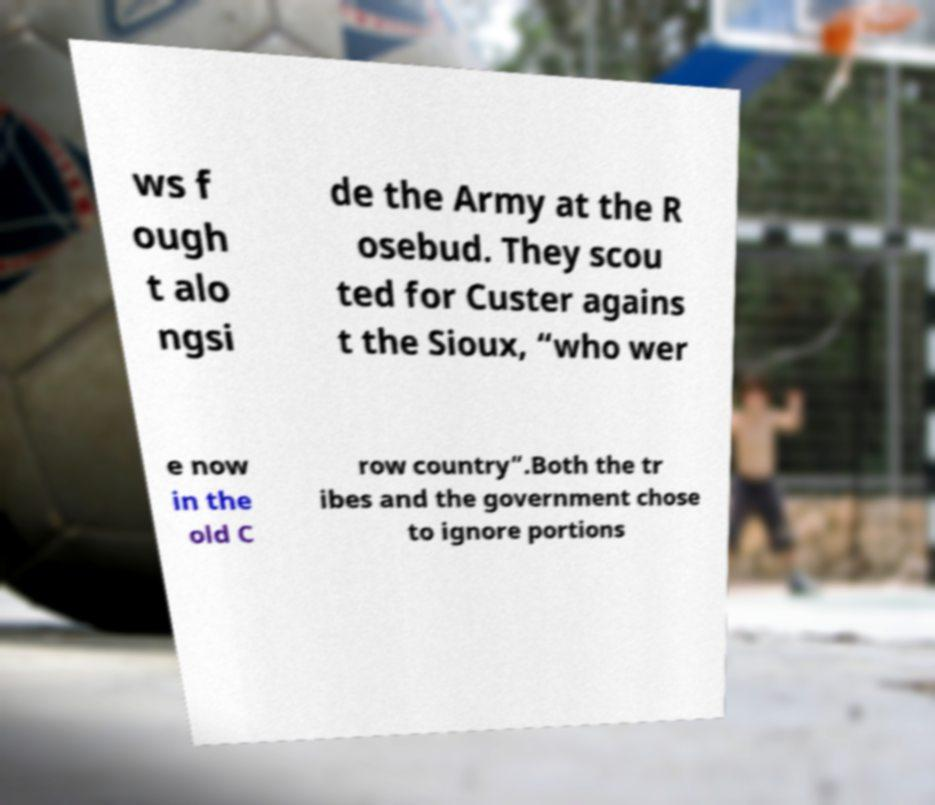For documentation purposes, I need the text within this image transcribed. Could you provide that? ws f ough t alo ngsi de the Army at the R osebud. They scou ted for Custer agains t the Sioux, “who wer e now in the old C row country”.Both the tr ibes and the government chose to ignore portions 